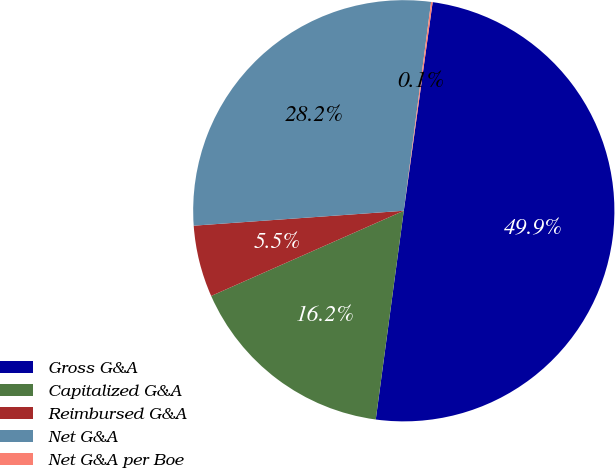<chart> <loc_0><loc_0><loc_500><loc_500><pie_chart><fcel>Gross G&A<fcel>Capitalized G&A<fcel>Reimbursed G&A<fcel>Net G&A<fcel>Net G&A per Boe<nl><fcel>49.94%<fcel>16.25%<fcel>5.5%<fcel>28.2%<fcel>0.12%<nl></chart> 